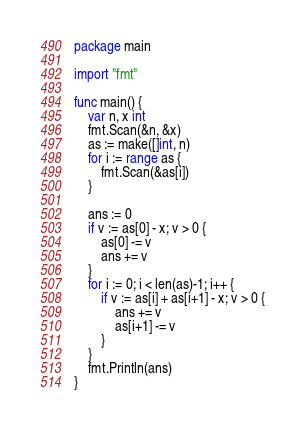<code> <loc_0><loc_0><loc_500><loc_500><_Go_>package main

import "fmt"

func main() {
	var n, x int
	fmt.Scan(&n, &x)
	as := make([]int, n)
	for i := range as {
		fmt.Scan(&as[i])
	}

	ans := 0
	if v := as[0] - x; v > 0 {
		as[0] -= v
		ans += v
	}
	for i := 0; i < len(as)-1; i++ {
		if v := as[i] + as[i+1] - x; v > 0 {
			ans += v
			as[i+1] -= v
		}
	}
	fmt.Println(ans)
}
</code> 